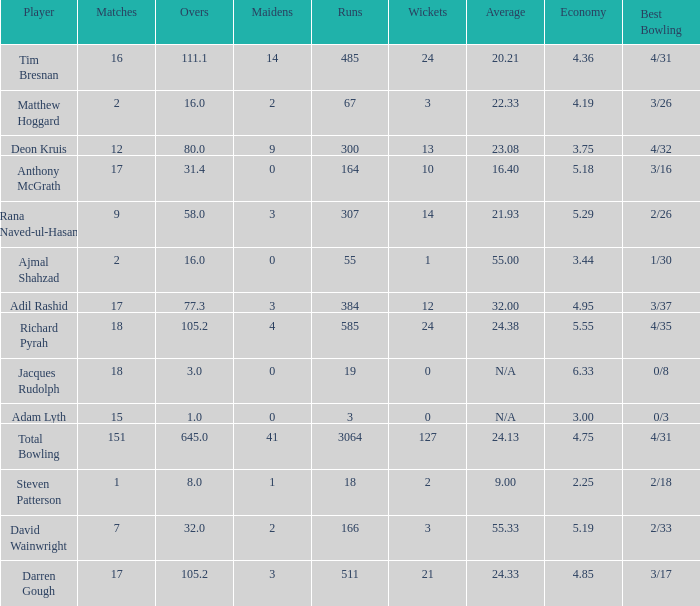What is the lowest Overs with a Run that is 18? 8.0. Parse the full table. {'header': ['Player', 'Matches', 'Overs', 'Maidens', 'Runs', 'Wickets', 'Average', 'Economy', 'Best Bowling'], 'rows': [['Tim Bresnan', '16', '111.1', '14', '485', '24', '20.21', '4.36', '4/31'], ['Matthew Hoggard', '2', '16.0', '2', '67', '3', '22.33', '4.19', '3/26'], ['Deon Kruis', '12', '80.0', '9', '300', '13', '23.08', '3.75', '4/32'], ['Anthony McGrath', '17', '31.4', '0', '164', '10', '16.40', '5.18', '3/16'], ['Rana Naved-ul-Hasan', '9', '58.0', '3', '307', '14', '21.93', '5.29', '2/26'], ['Ajmal Shahzad', '2', '16.0', '0', '55', '1', '55.00', '3.44', '1/30'], ['Adil Rashid', '17', '77.3', '3', '384', '12', '32.00', '4.95', '3/37'], ['Richard Pyrah', '18', '105.2', '4', '585', '24', '24.38', '5.55', '4/35'], ['Jacques Rudolph', '18', '3.0', '0', '19', '0', 'N/A', '6.33', '0/8'], ['Adam Lyth', '15', '1.0', '0', '3', '0', 'N/A', '3.00', '0/3'], ['Total Bowling', '151', '645.0', '41', '3064', '127', '24.13', '4.75', '4/31'], ['Steven Patterson', '1', '8.0', '1', '18', '2', '9.00', '2.25', '2/18'], ['David Wainwright', '7', '32.0', '2', '166', '3', '55.33', '5.19', '2/33'], ['Darren Gough', '17', '105.2', '3', '511', '21', '24.33', '4.85', '3/17']]} 